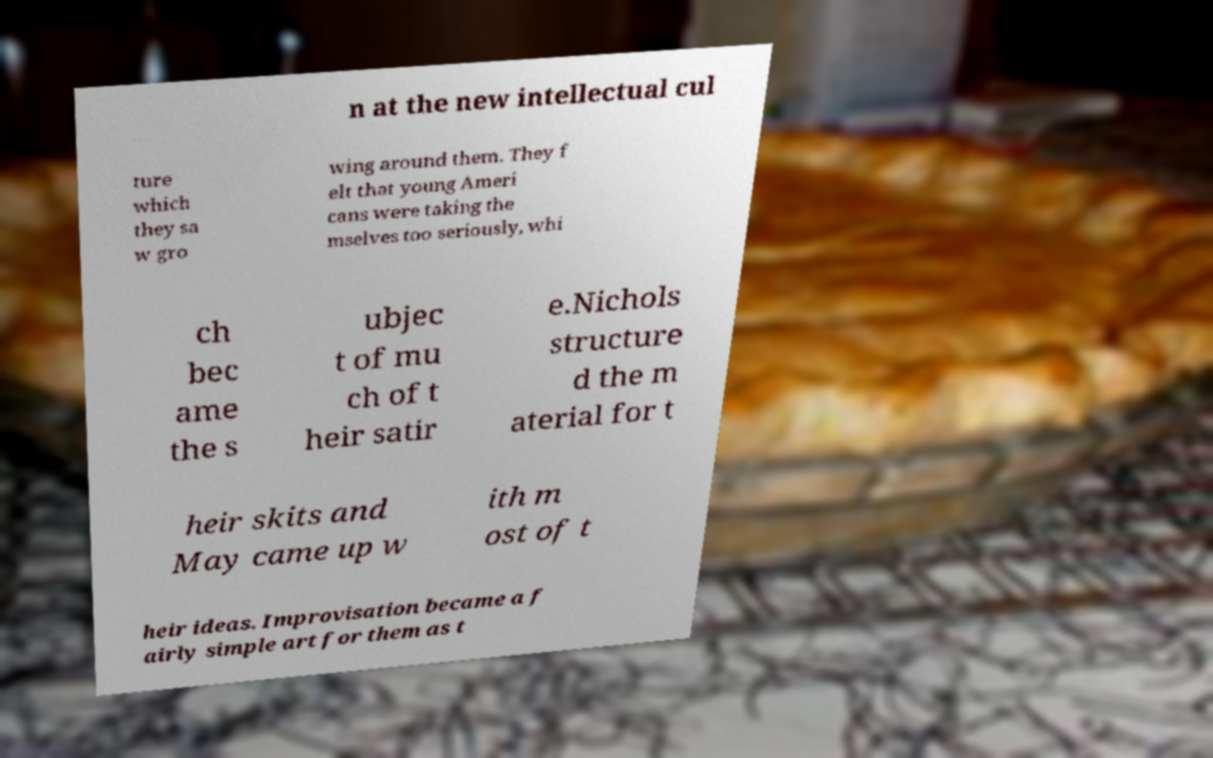Please read and relay the text visible in this image. What does it say? n at the new intellectual cul ture which they sa w gro wing around them. They f elt that young Ameri cans were taking the mselves too seriously, whi ch bec ame the s ubjec t of mu ch of t heir satir e.Nichols structure d the m aterial for t heir skits and May came up w ith m ost of t heir ideas. Improvisation became a f airly simple art for them as t 